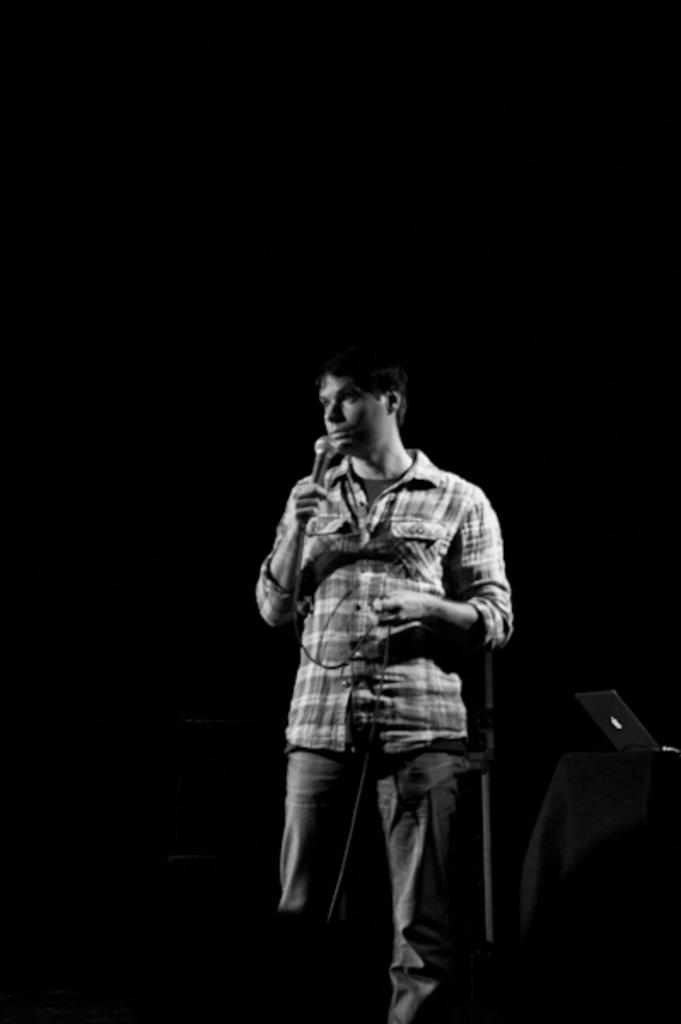What is the main subject of the image? The main subject of the image is a man standing in the middle. What is the man wearing in the image? The man is wearing a shirt and trousers. What object is the man holding in his hand? The man is holding a microphone in his hand. Where is the faucet located in the image? There is no faucet present in the image. What type of bulb is being used by the man in the image? The man is not using any bulb in the image; he is holding a microphone. 